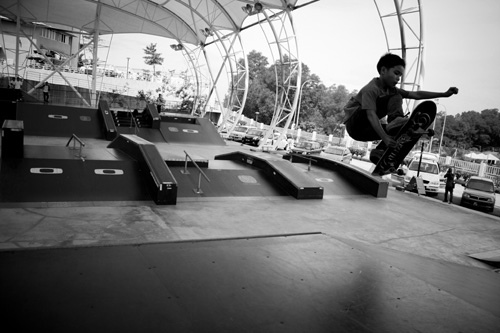Read and extract the text from this image. O O 